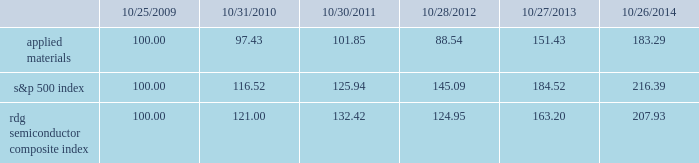Performance graph the performance graph below shows the five-year cumulative total stockholder return on applied common stock during the period from october 25 , 2009 through october 26 , 2014 .
This is compared with the cumulative total return of the standard & poor 2019s 500 stock index and the rdg semiconductor composite index over the same period .
The comparison assumes $ 100 was invested on october 25 , 2009 in applied common stock and in each of the foregoing indices and assumes reinvestment of dividends , if any .
Dollar amounts in the graph are rounded to the nearest whole dollar .
The performance shown in the graph represents past performance and should not be considered an indication of future performance .
Comparison of 5 year cumulative total return* among applied materials , inc. , the s&p 500 index 201cs&p 201d is a registered trademark of standard & poor 2019s financial services llc , a subsidiary of the mcgraw-hill companies , inc. .
Dividends during fiscal 2014 , applied 2019s board of directors declared four quarterly cash dividends of $ 0.10 per share each .
During fiscal 2013 , applied 2019s board of directors declared three quarterly cash dividends of $ 0.10 per share each and one quarterly cash dividend of $ 0.09 per share .
During fiscal 2012 , applied 2019s board of directors declared three quarterly cash dividends of $ 0.09 per share each and one quarterly cash dividend of $ 0.08 .
Dividends declared during fiscal 2014 , 2013 and 2012 totaled $ 487 million , $ 469 million and $ 438 million , respectively .
Applied currently anticipates that it will continue to pay cash dividends on a quarterly basis in the future , although the declaration and amount of any future cash dividends are at the discretion of the board of directors and will depend on applied 2019s financial condition , results of operations , capital requirements , business conditions and other factors , as well as a determination that cash dividends are in the best interests of applied 2019s stockholders .
$ 100 invested on 10/25/09 in stock or 10/31/09 in index , including reinvestment of dividends .
Indexes calculated on month-end basis .
And the rdg semiconductor composite index 183145 97 102 121 132 10/25/09 10/31/10 10/30/11 10/28/12 10/27/13 10/26/14 applied materials , inc .
S&p 500 rdg semiconductor composite .
How much more return was given for investing in the overall market rather than applied materials from 2009 to 2014 ? ( in a percentage )? 
Rationale: to figure out the percentage return , we need to find out how much each one grew over the years first . one can do this by subtracting by 100 and making that number a percentage because we started at 100 . then we subtract the two percentages to find out how much more return one stock gave us .
Computations: ((216.39 - 100) - (183.29 - 100))
Answer: 33.1. 